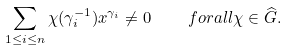Convert formula to latex. <formula><loc_0><loc_0><loc_500><loc_500>\sum _ { 1 \leq i \leq n } { \chi } ( \gamma _ { i } ^ { - 1 } ) x ^ { \gamma _ { i } } \neq 0 \quad f o r a l l \chi \in \widehat { G } .</formula> 